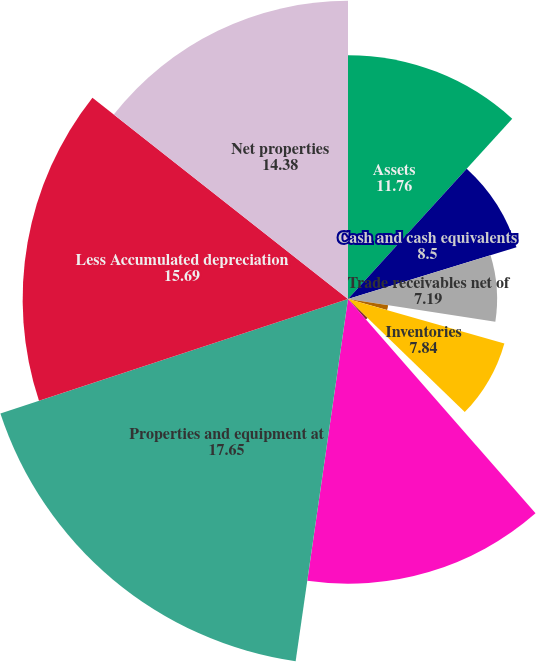Convert chart. <chart><loc_0><loc_0><loc_500><loc_500><pie_chart><fcel>Assets<fcel>Cash and cash equivalents<fcel>Trade receivables net of<fcel>Miscellaneous receivables<fcel>Inventories<fcel>Other current assets<fcel>Total current assets<fcel>Properties and equipment at<fcel>Less Accumulated depreciation<fcel>Net properties<nl><fcel>11.76%<fcel>8.5%<fcel>7.19%<fcel>1.96%<fcel>7.84%<fcel>1.31%<fcel>13.73%<fcel>17.65%<fcel>15.69%<fcel>14.38%<nl></chart> 